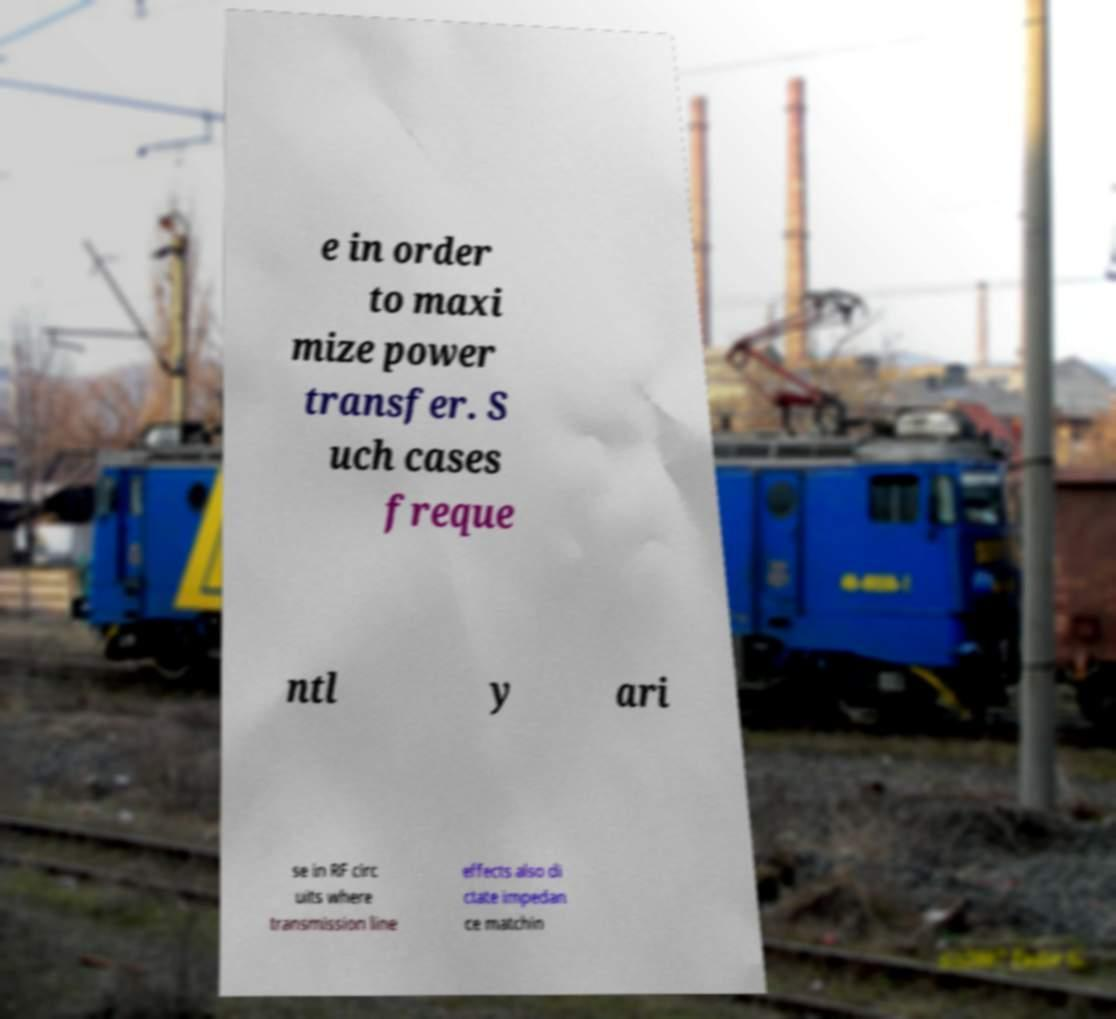I need the written content from this picture converted into text. Can you do that? e in order to maxi mize power transfer. S uch cases freque ntl y ari se in RF circ uits where transmission line effects also di ctate impedan ce matchin 